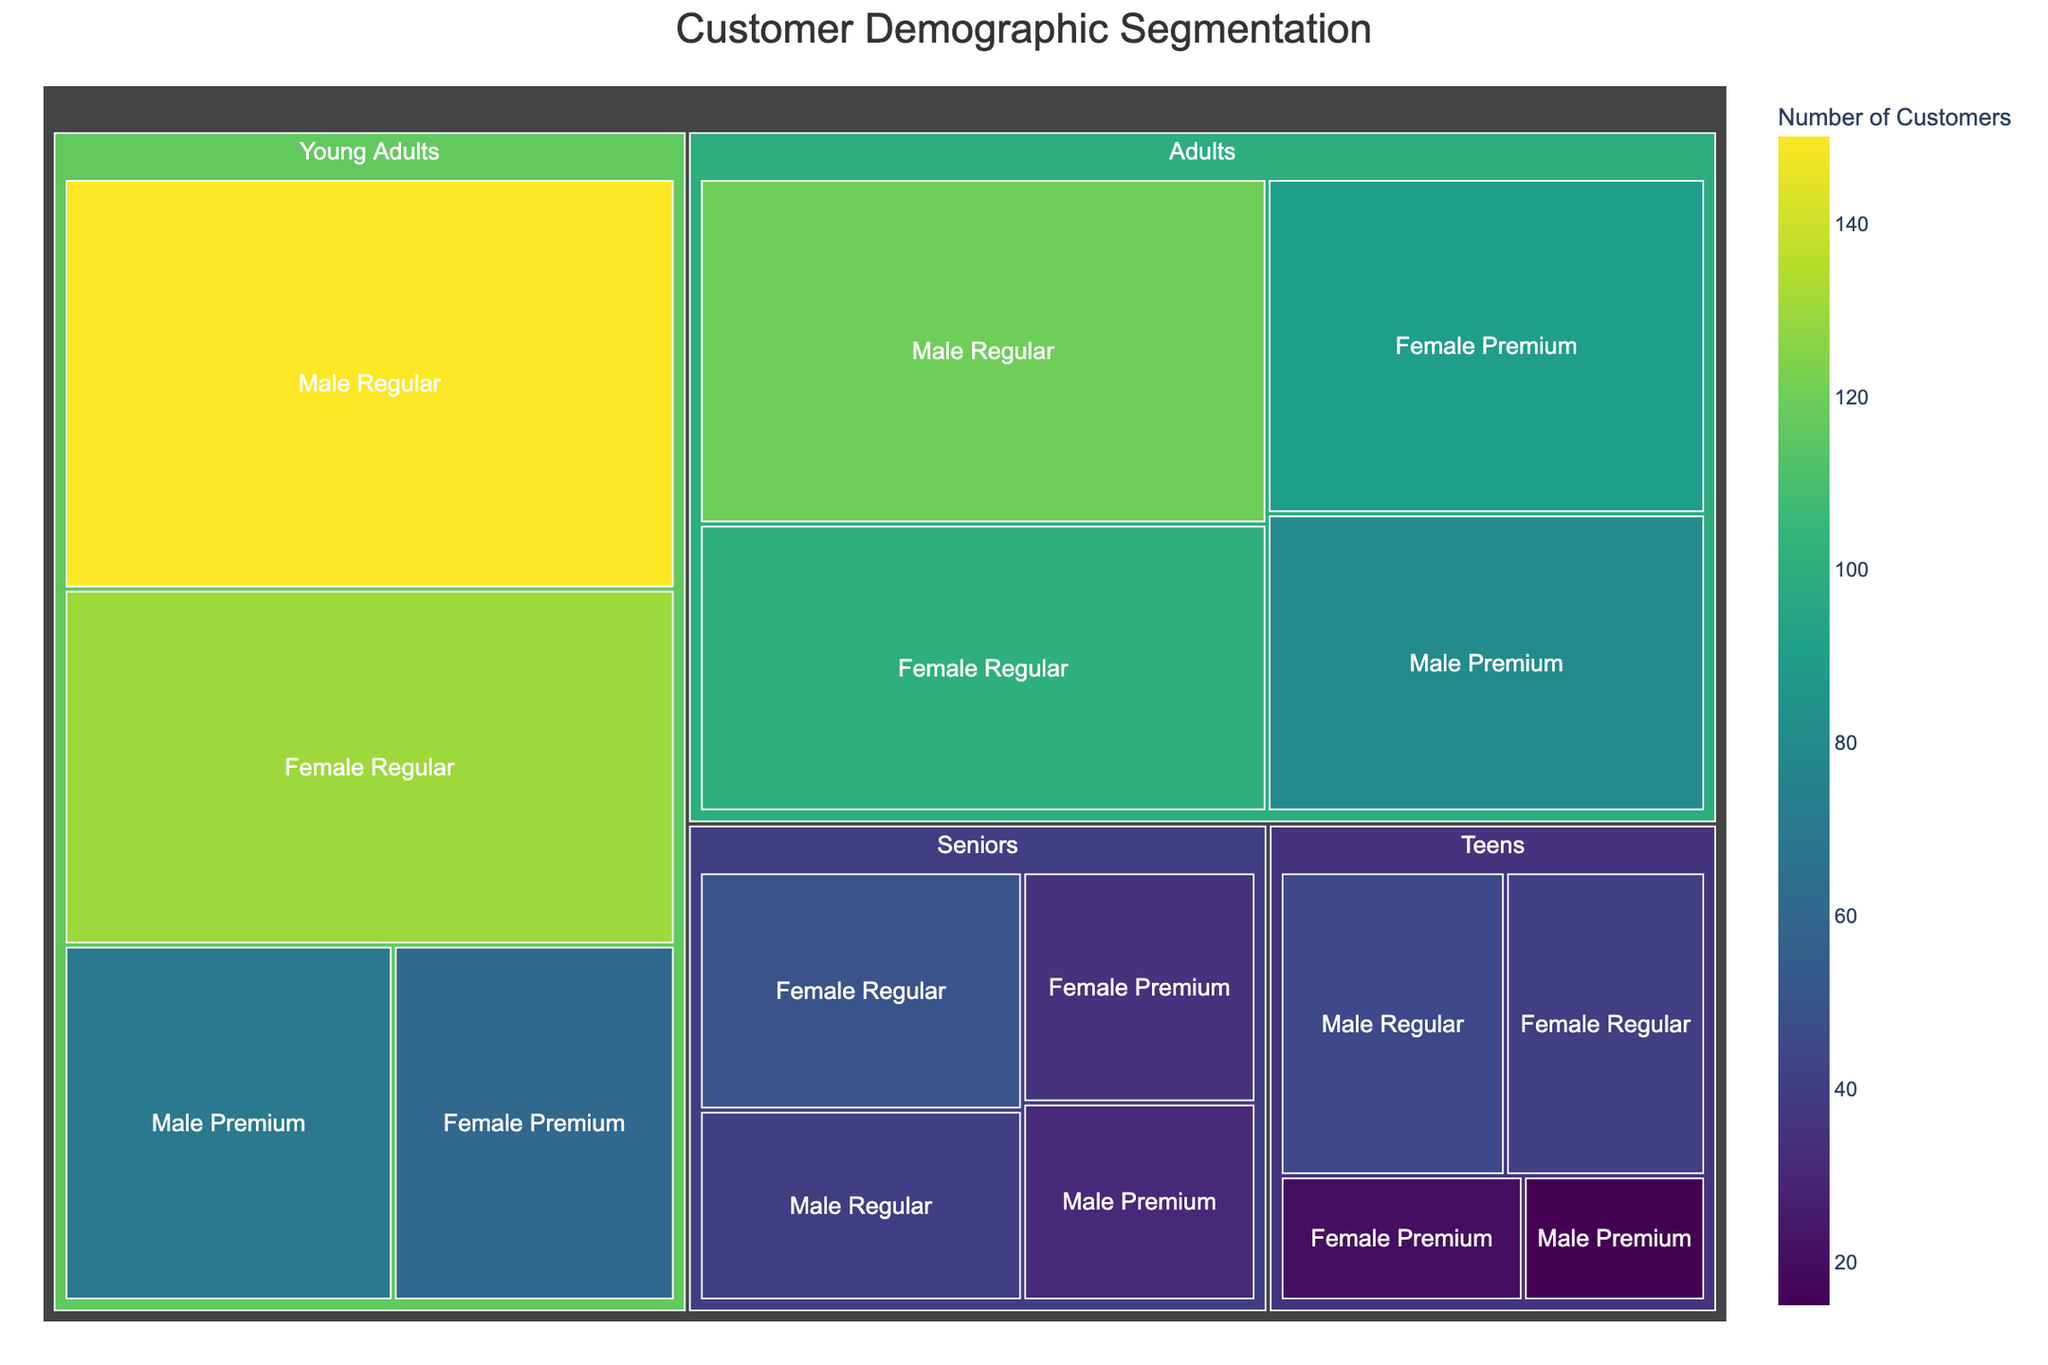Which category has the most customers? By observing the largest area on the treemap, the 'Young Adults' category has the highest total number of customers. Adding the values under 'Young Adults' (150 + 70 + 130 + 60) gives 410, which is higher compared to other categories.
Answer: Young Adults How many customers are in the 'Seniors' category? Sum the values of all subcategories under the 'Seniors' category: 40 (Male Regular) + 30 (Male Premium) + 50 (Female Regular) + 35 (Female Premium), which totals 155.
Answer: 155 Which subcategory under 'Adults' has the least number of customers? The values under 'Adults' are 120 (Male Regular), 80 (Male Premium), 100 (Female Regular), and 90 (Female Premium). The lowest value among these is 80.
Answer: Male Premium What is the difference in the number of customers between 'Teens Male Regular' and 'Teens Female Regular'? The values for 'Teens Male Regular' and 'Teens Female Regular' are 45 and 40 respectively. The difference is 45 - 40 = 5.
Answer: 5 What is the ratio of 'Young Adults Female Regular' to 'Young Adults Male Regular'? The values for 'Young Adults Female Regular' and 'Young Adults Male Regular' are 130 and 150 respectively. The ratio is 130/150 = 0.87.
Answer: 0.87 Compare the number of regular vs. premium members in the 'Young Adults' category. The sum of regular members in 'Young Adults' is 150 (Male) + 130 (Female) = 280. The sum of premium members is 70 (Male) + 60 (Female) = 130.
Answer: 280 vs 130 